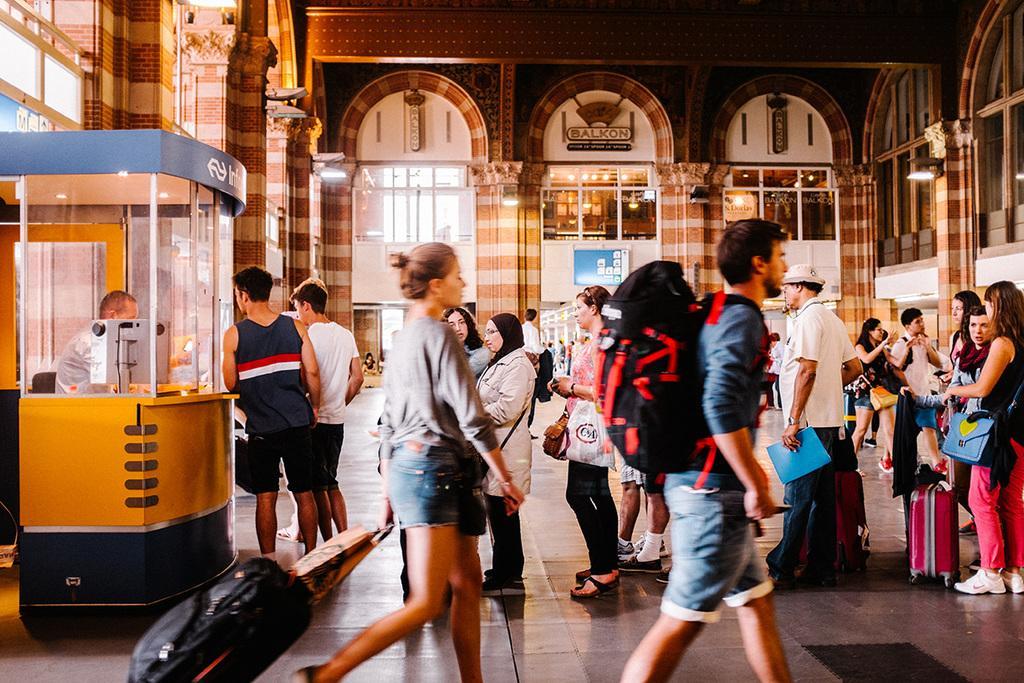Please provide a concise description of this image. In the picture we can see a hall with some people are standing in a queue near the counter and in it we can see a man sitting near the desk with monitor on it and some people are walking with travelling bags and in the background we can see pillars and glass walls. 